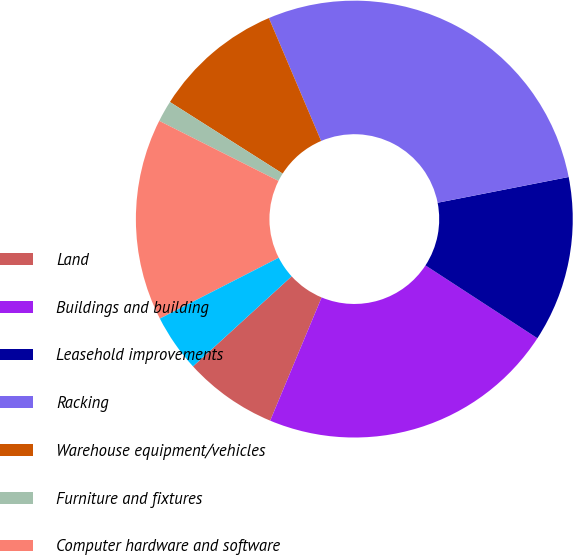Convert chart. <chart><loc_0><loc_0><loc_500><loc_500><pie_chart><fcel>Land<fcel>Buildings and building<fcel>Leasehold improvements<fcel>Racking<fcel>Warehouse equipment/vehicles<fcel>Furniture and fixtures<fcel>Computer hardware and software<fcel>Construction in progress<nl><fcel>6.93%<fcel>22.11%<fcel>12.27%<fcel>28.31%<fcel>9.6%<fcel>1.58%<fcel>14.95%<fcel>4.25%<nl></chart> 